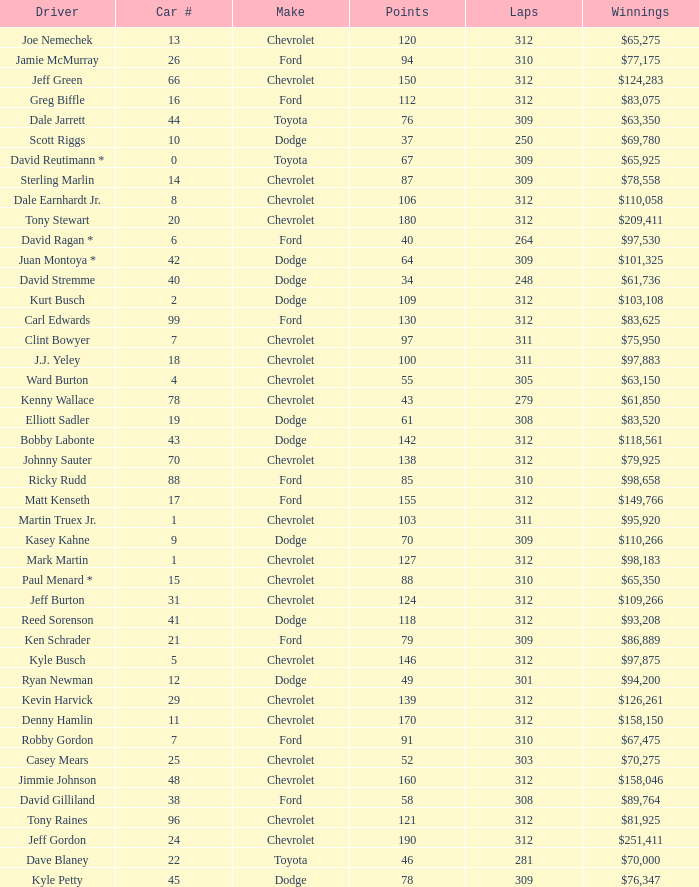What is the sum of laps that has a car number of larger than 1, is a ford, and has 155 points? 312.0. 